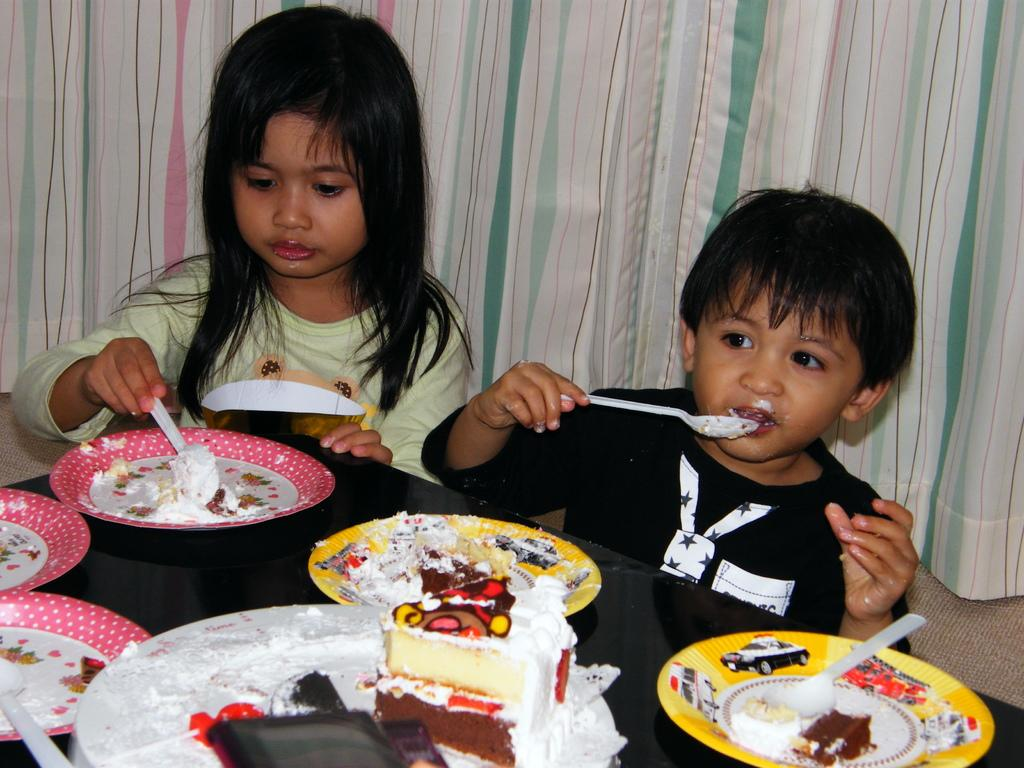How many children are in the image? There are two children in the image. Where are the children sitting in relation to the table? The children are sitting near a table. What is on the plates that are on the table? There are plates with cake on the table. What can be seen in the background of the image? There is a curtain visible in the background of the image. What is the income of the father in the image? There is no information about the father or their income in the image. Can you touch the cake on the table in the image? The image is a static representation, so you cannot physically touch the cake or any other objects in the image. 